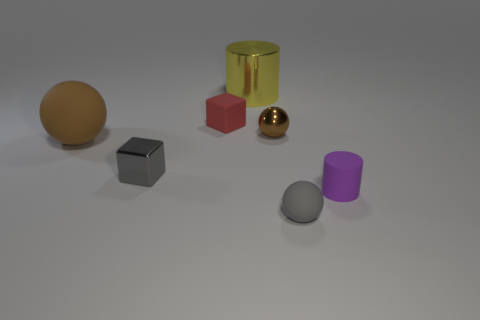There is a rubber sphere behind the gray object that is right of the shiny thing that is in front of the brown shiny object; how big is it?
Your answer should be compact. Large. How many other things are the same size as the gray sphere?
Offer a very short reply. 4. How many yellow cylinders have the same material as the small red block?
Keep it short and to the point. 0. The tiny gray thing that is behind the purple cylinder has what shape?
Offer a very short reply. Cube. Do the big sphere and the small block that is behind the big brown sphere have the same material?
Offer a very short reply. Yes. Are there any tiny purple matte objects?
Keep it short and to the point. Yes. Is there a tiny gray matte sphere behind the sphere that is in front of the brown thing on the left side of the big yellow metal cylinder?
Give a very brief answer. No. What number of big things are purple matte things or blue cubes?
Your answer should be very brief. 0. There is a rubber ball that is the same size as the purple matte object; what is its color?
Provide a short and direct response. Gray. What number of small gray rubber things are left of the brown metallic object?
Provide a succinct answer. 0. 